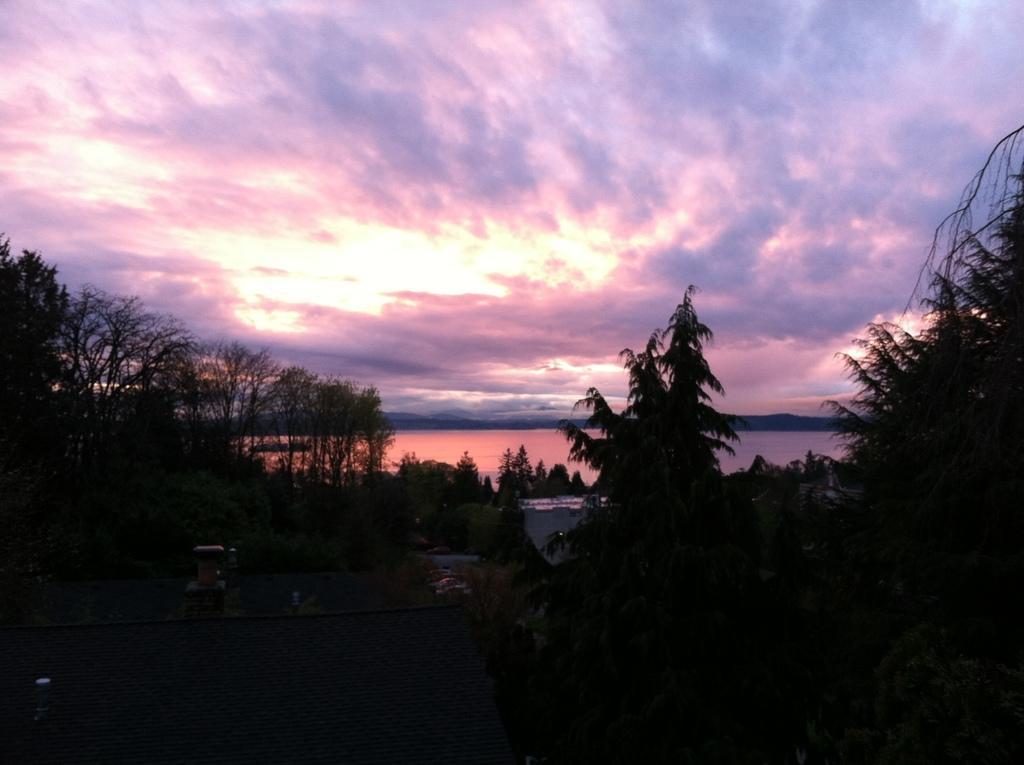Could you give a brief overview of what you see in this image? As we can see in the image there are trees, water, sky and clouds. The image is little dark. 